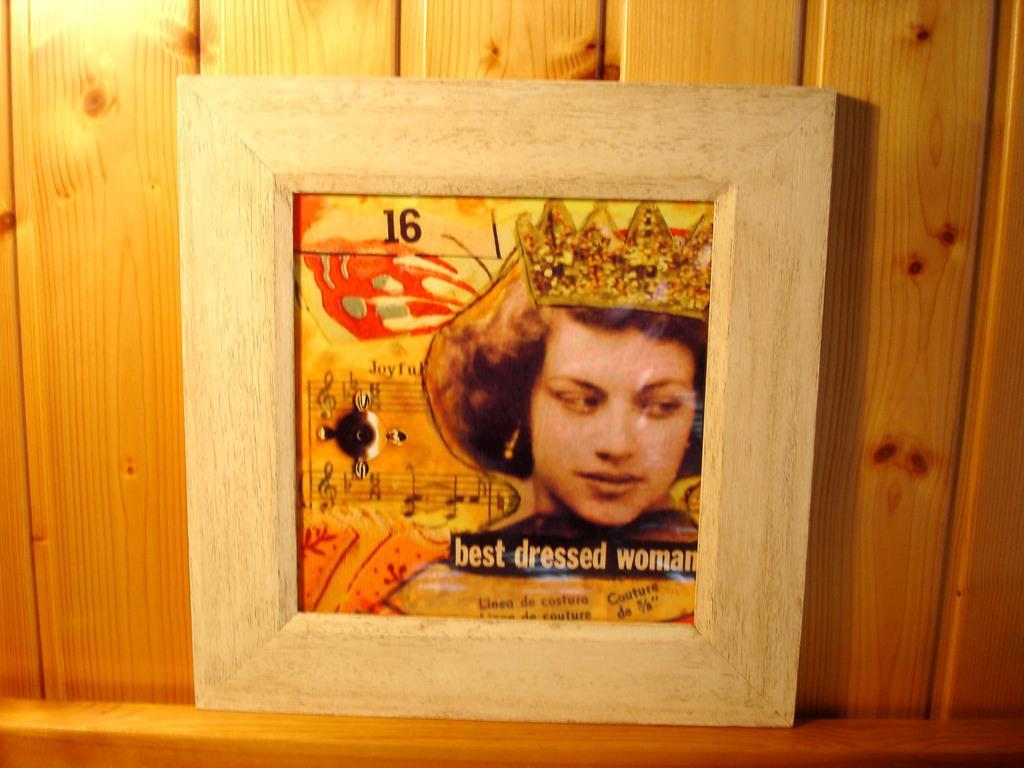Could you give a brief overview of what you see in this image? In this picture I can see a photo frame in front and on the photo I can see a picture of a woman and I see few words and numbers written. In the background I can see the wooden wall. 